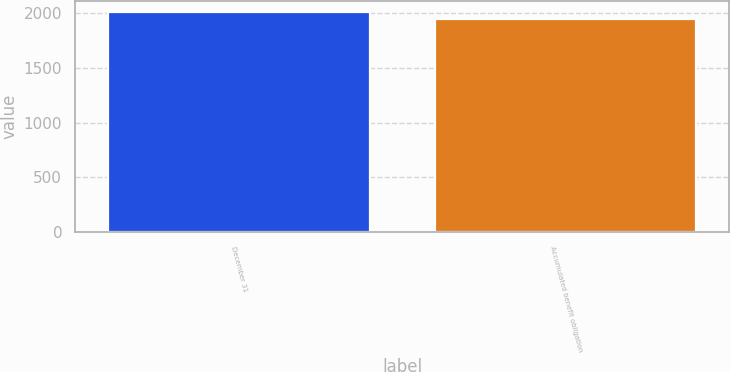Convert chart. <chart><loc_0><loc_0><loc_500><loc_500><bar_chart><fcel>December 31<fcel>Accumulated benefit obligation<nl><fcel>2013<fcel>1950<nl></chart> 